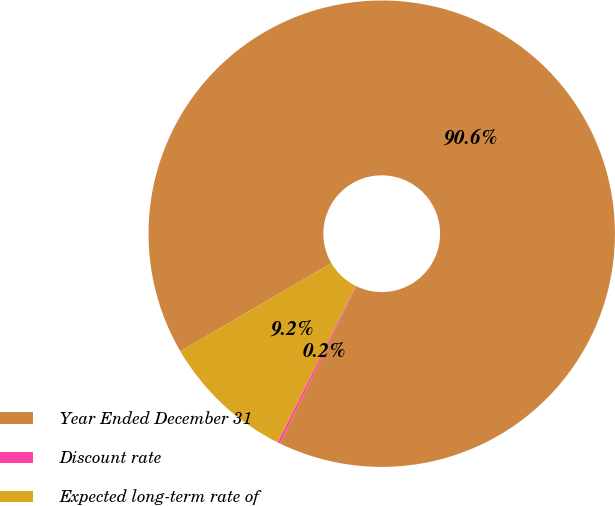Convert chart. <chart><loc_0><loc_0><loc_500><loc_500><pie_chart><fcel>Year Ended December 31<fcel>Discount rate<fcel>Expected long-term rate of<nl><fcel>90.6%<fcel>0.18%<fcel>9.22%<nl></chart> 